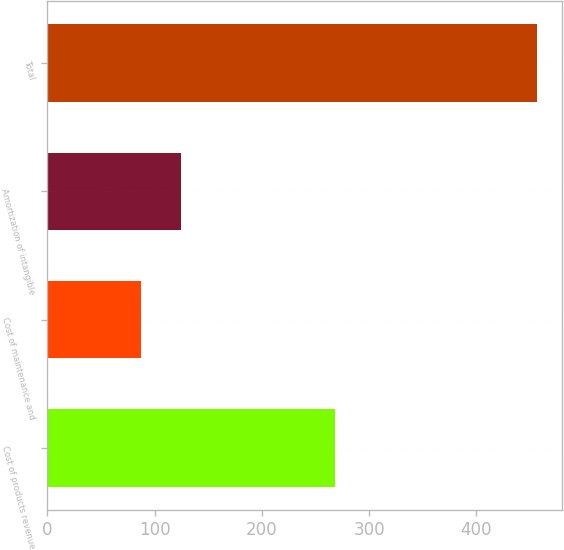Convert chart. <chart><loc_0><loc_0><loc_500><loc_500><bar_chart><fcel>Cost of products revenue<fcel>Cost of maintenance and<fcel>Amortization of intangible<fcel>Total<nl><fcel>268.4<fcel>87.2<fcel>124.17<fcel>456.9<nl></chart> 